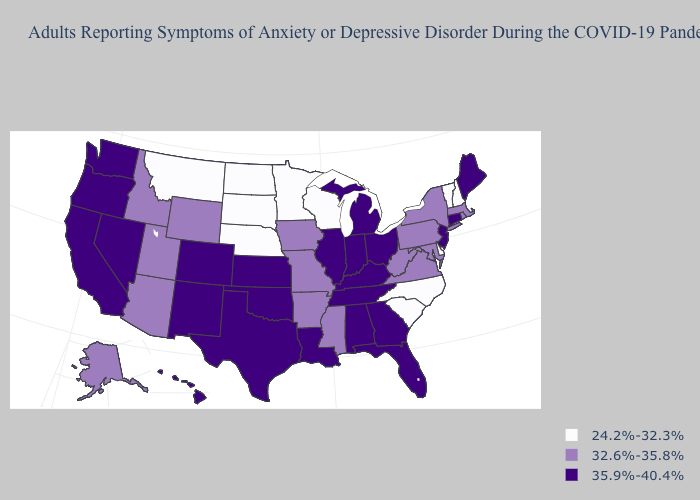What is the value of Virginia?
Give a very brief answer. 32.6%-35.8%. Among the states that border Ohio , does Michigan have the highest value?
Keep it brief. Yes. Name the states that have a value in the range 32.6%-35.8%?
Answer briefly. Alaska, Arizona, Arkansas, Idaho, Iowa, Maryland, Massachusetts, Mississippi, Missouri, New York, Pennsylvania, Rhode Island, Utah, Virginia, West Virginia, Wyoming. What is the lowest value in the USA?
Concise answer only. 24.2%-32.3%. How many symbols are there in the legend?
Answer briefly. 3. What is the value of Minnesota?
Keep it brief. 24.2%-32.3%. Name the states that have a value in the range 24.2%-32.3%?
Write a very short answer. Delaware, Minnesota, Montana, Nebraska, New Hampshire, North Carolina, North Dakota, South Carolina, South Dakota, Vermont, Wisconsin. What is the value of Pennsylvania?
Quick response, please. 32.6%-35.8%. Name the states that have a value in the range 35.9%-40.4%?
Keep it brief. Alabama, California, Colorado, Connecticut, Florida, Georgia, Hawaii, Illinois, Indiana, Kansas, Kentucky, Louisiana, Maine, Michigan, Nevada, New Jersey, New Mexico, Ohio, Oklahoma, Oregon, Tennessee, Texas, Washington. Which states have the lowest value in the USA?
Write a very short answer. Delaware, Minnesota, Montana, Nebraska, New Hampshire, North Carolina, North Dakota, South Carolina, South Dakota, Vermont, Wisconsin. Does West Virginia have a higher value than Virginia?
Give a very brief answer. No. What is the value of Connecticut?
Write a very short answer. 35.9%-40.4%. Name the states that have a value in the range 24.2%-32.3%?
Quick response, please. Delaware, Minnesota, Montana, Nebraska, New Hampshire, North Carolina, North Dakota, South Carolina, South Dakota, Vermont, Wisconsin. Is the legend a continuous bar?
Write a very short answer. No. Does Michigan have the highest value in the MidWest?
Be succinct. Yes. 